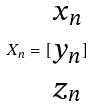Convert formula to latex. <formula><loc_0><loc_0><loc_500><loc_500>X _ { n } = [ \begin{matrix} x _ { n } \\ y _ { n } \\ z _ { n } \end{matrix} ]</formula> 